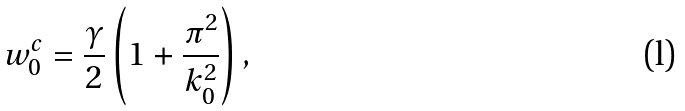<formula> <loc_0><loc_0><loc_500><loc_500>w _ { 0 } ^ { c } = \frac { \gamma } { 2 } \left ( 1 + \frac { \pi ^ { 2 } } { k _ { 0 } ^ { 2 } } \right ) ,</formula> 